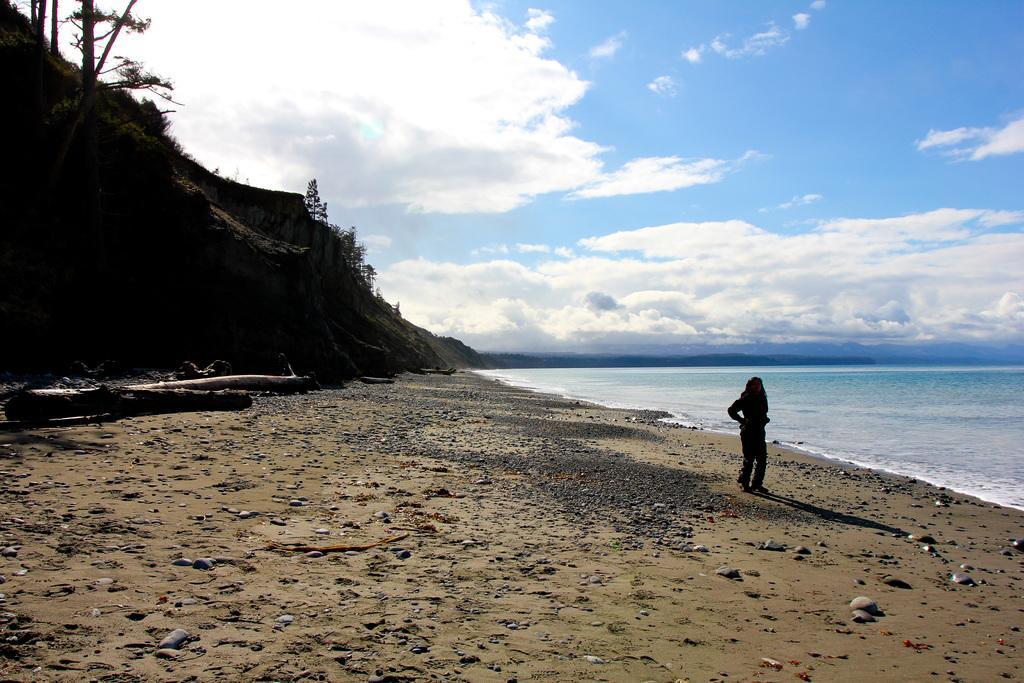How would you summarize this image in a sentence or two? In the given picture, I can see an ocean and women standing, few stones, couple of trees, sky, clouds finally a stones. 